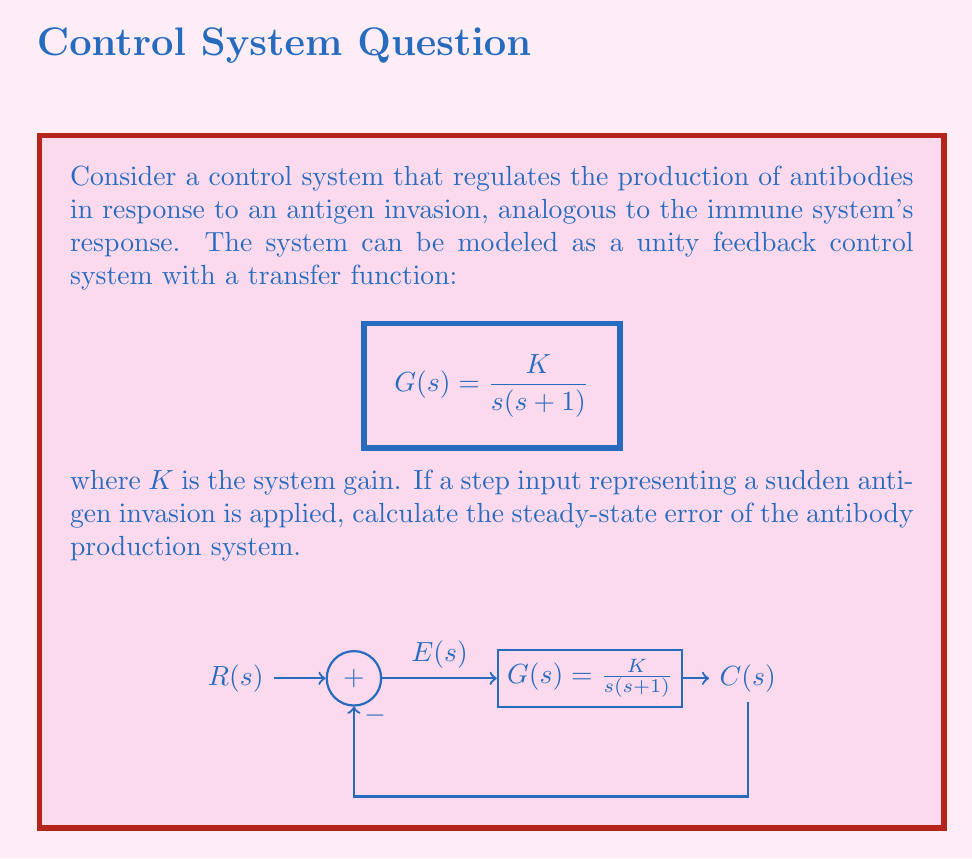Solve this math problem. To calculate the steady-state error for a step input, we'll follow these steps:

1) The step input in the s-domain is represented as $R(s) = \frac{1}{s}$.

2) For unity feedback systems, the steady-state error is given by:

   $$e_{ss} = \lim_{s \to 0} \frac{s}{1 + G(s)} \cdot \frac{R(s)}{s}$$

3) Substitute $G(s) = \frac{K}{s(s+1)}$ and $R(s) = \frac{1}{s}$ into the equation:

   $$e_{ss} = \lim_{s \to 0} \frac{s}{1 + \frac{K}{s(s+1)}} \cdot \frac{1}{s^2}$$

4) Simplify the expression:

   $$e_{ss} = \lim_{s \to 0} \frac{s^2(s+1)}{s^2(s+1) + K} \cdot \frac{1}{s^2}$$

5) Cancel out $s^2$ in the numerator and denominator:

   $$e_{ss} = \lim_{s \to 0} \frac{s+1}{s^2(s+1) + K}$$

6) As $s$ approaches 0, $s^2$ and $s$ terms approach 0:

   $$e_{ss} = \frac{1}{K}$$

This result shows that the steady-state error is inversely proportional to the system gain $K$. In the context of antibody production, a higher gain would result in a smaller steady-state error, meaning the immune system would more accurately match the antibody production to the antigen invasion level.
Answer: $e_{ss} = \frac{1}{K}$ 